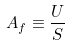<formula> <loc_0><loc_0><loc_500><loc_500>A _ { f } \equiv \frac { U } { S }</formula> 